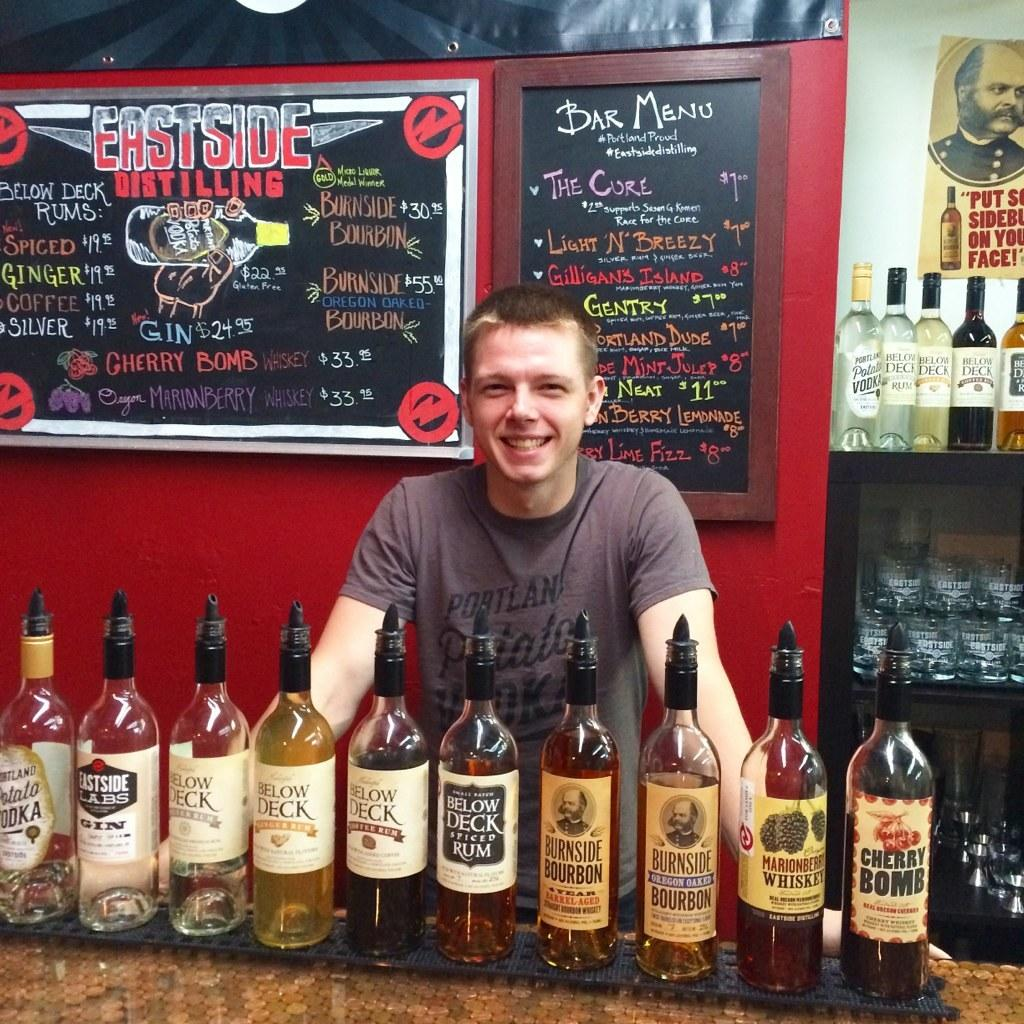<image>
Give a short and clear explanation of the subsequent image. A smiling man has bottles of below Deck rum and other liquors lined up in front of him. 